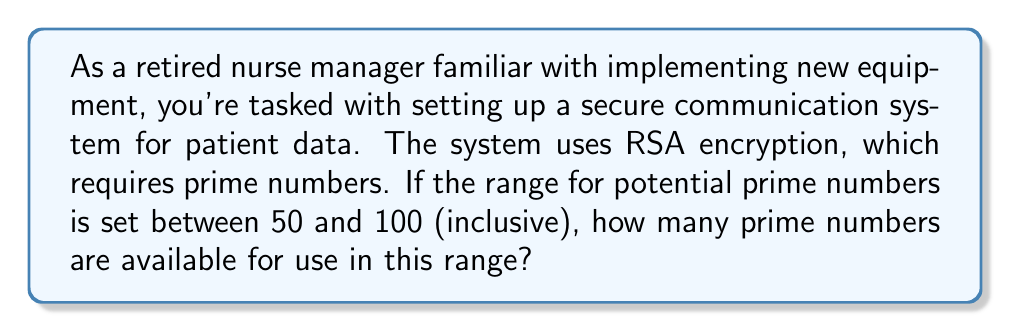What is the answer to this math problem? To solve this problem, we'll follow these steps:

1) First, let's recall the definition of a prime number: a natural number greater than 1 that is only divisible by 1 and itself.

2) We need to check each number from 50 to 100 for primality. A efficient way to do this is using the Sieve of Eratosthenes method:

   a) Create a list of all integers from 50 to 100.
   b) Start with the smallest prime number greater than $\sqrt{100}$, which is 11.
   c) Cross out all multiples of 11 in our range.
   d) Repeat for the next prime number (13) until we reach 100.

3) After applying the Sieve, the remaining numbers are prime. Let's list them:

   53, 59, 61, 67, 71, 73, 79, 83, 89, 97

4) Count the number of primes in this list.

The mathematical representation of this count can be expressed as:

$$\pi(100) - \pi(49)$$

Where $\pi(x)$ is the prime-counting function that gives the number of primes less than or equal to $x$.
Answer: 10 